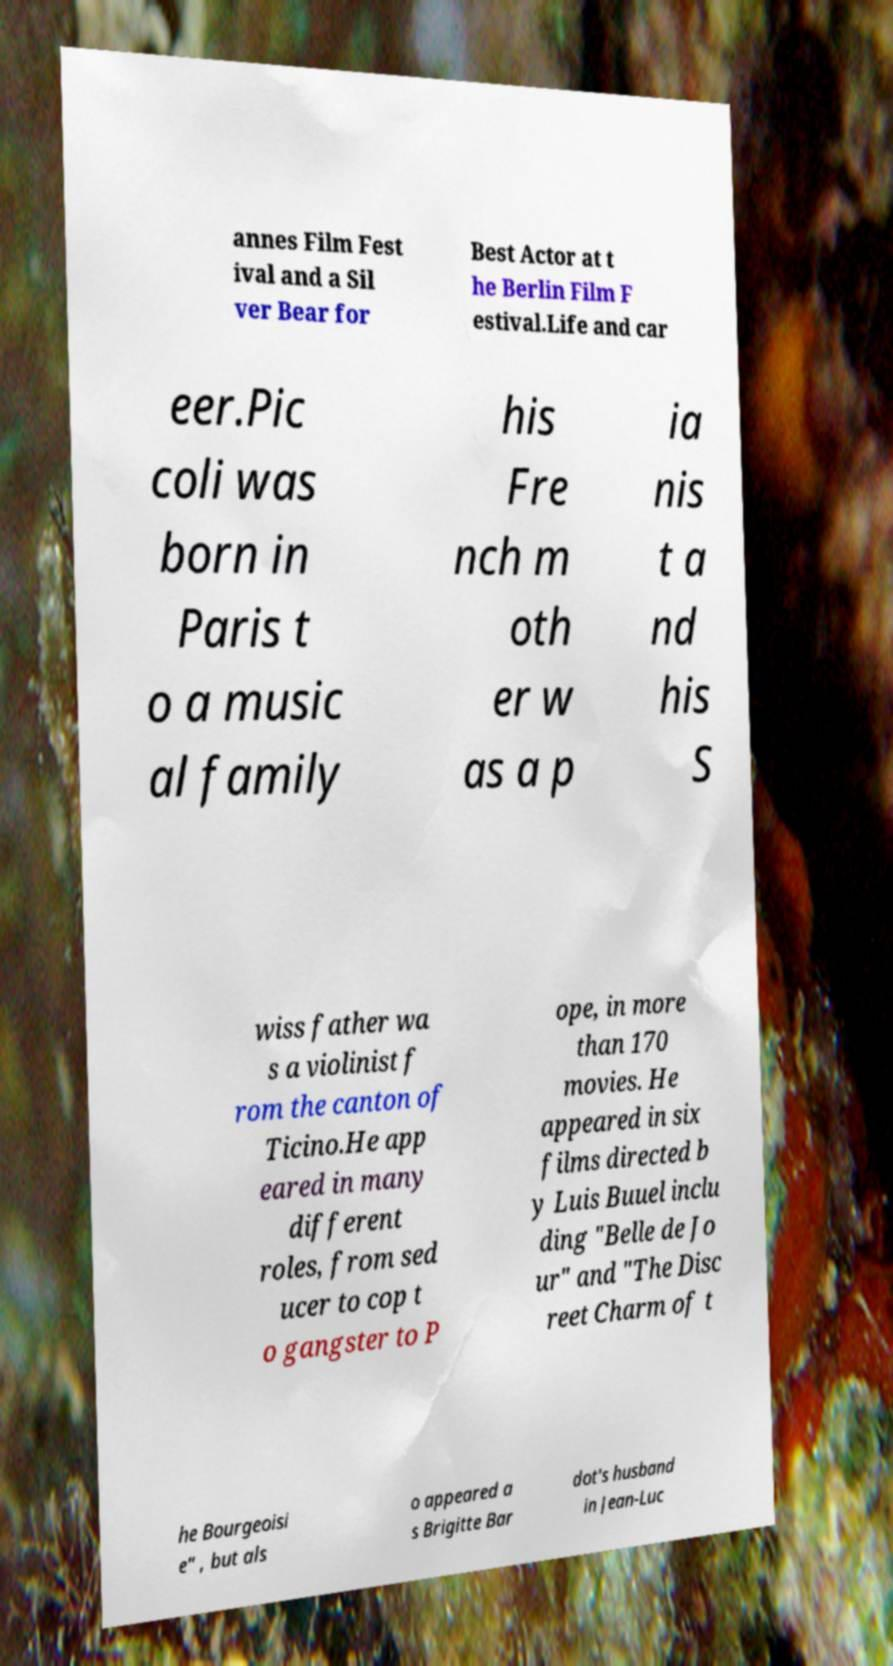What messages or text are displayed in this image? I need them in a readable, typed format. annes Film Fest ival and a Sil ver Bear for Best Actor at t he Berlin Film F estival.Life and car eer.Pic coli was born in Paris t o a music al family his Fre nch m oth er w as a p ia nis t a nd his S wiss father wa s a violinist f rom the canton of Ticino.He app eared in many different roles, from sed ucer to cop t o gangster to P ope, in more than 170 movies. He appeared in six films directed b y Luis Buuel inclu ding "Belle de Jo ur" and "The Disc reet Charm of t he Bourgeoisi e" , but als o appeared a s Brigitte Bar dot's husband in Jean-Luc 